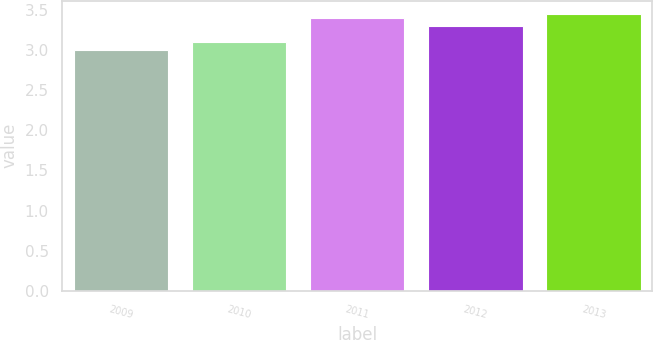Convert chart. <chart><loc_0><loc_0><loc_500><loc_500><bar_chart><fcel>2009<fcel>2010<fcel>2011<fcel>2012<fcel>2013<nl><fcel>3<fcel>3.1<fcel>3.4<fcel>3.3<fcel>3.44<nl></chart> 